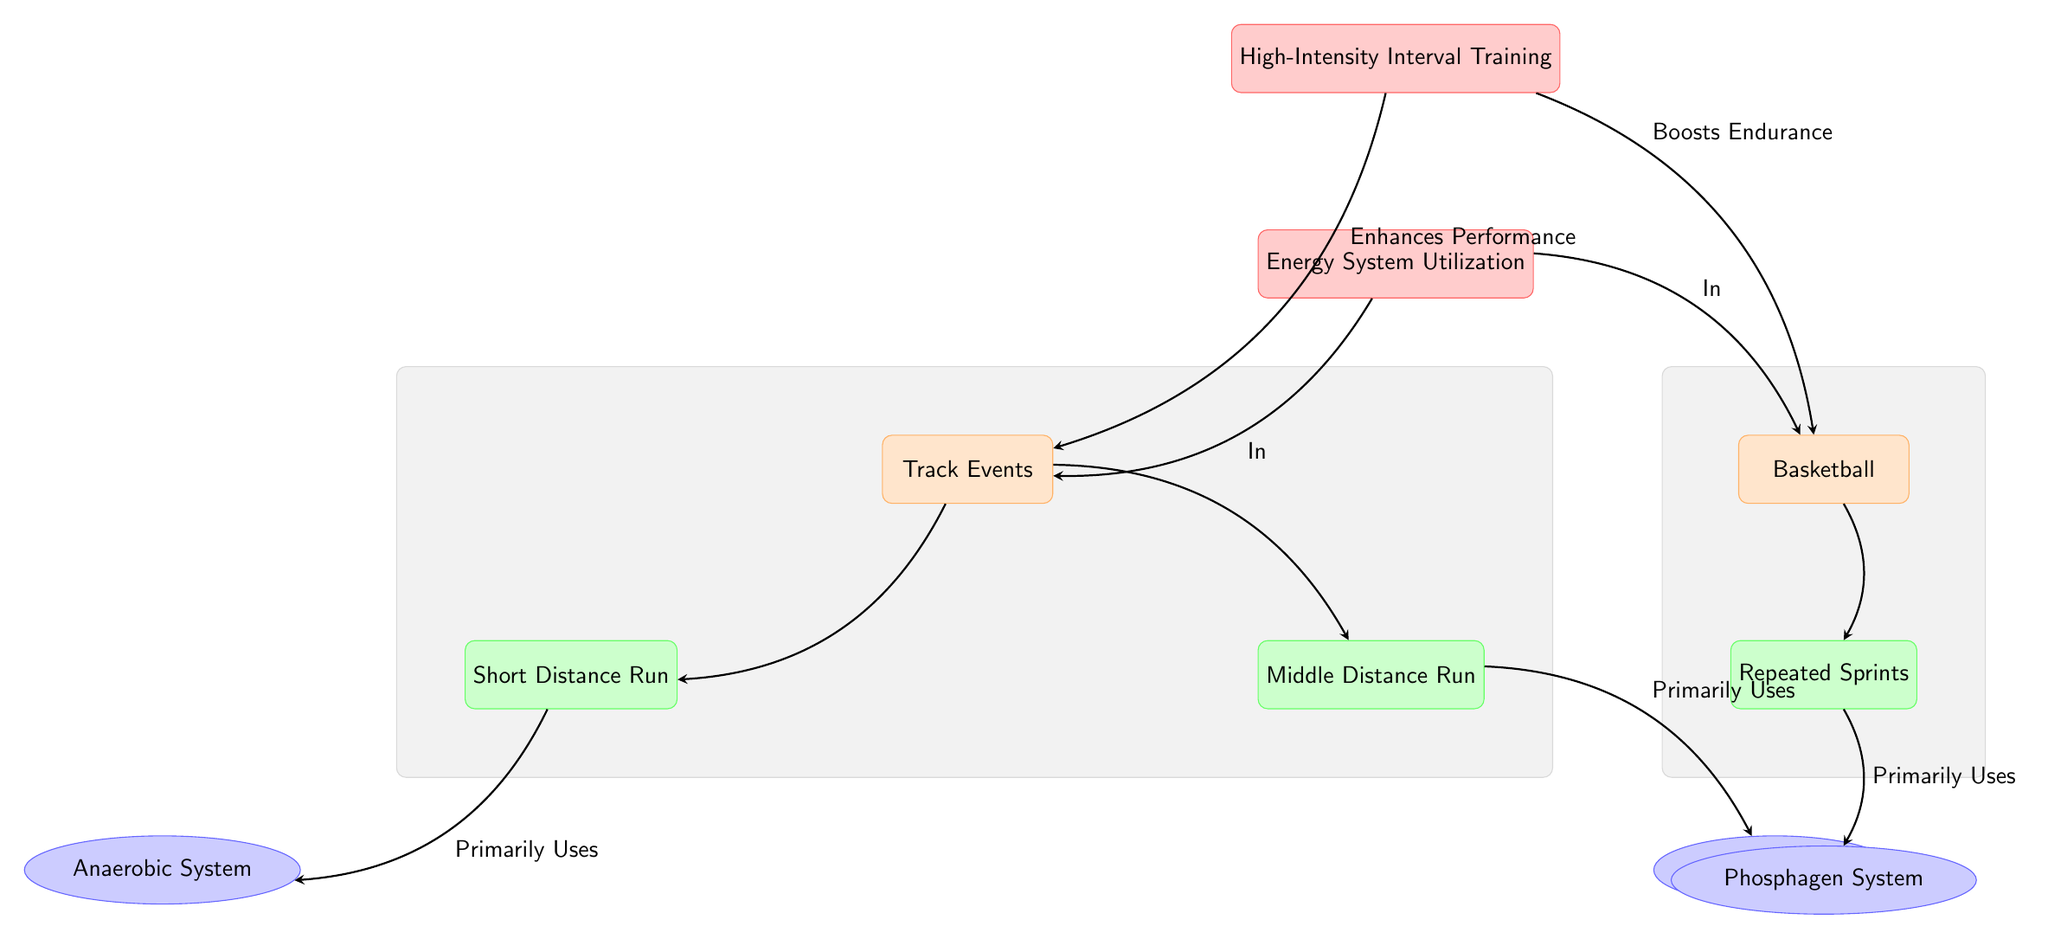What are the two primary energy systems utilized in short distance runs? The diagram indicates that the short distance runs primarily use the anaerobic system as shown by the arrow from the short distance run to the anaerobic system.
Answer: Anaerobic System What type of training enhances performance in track events? The arrow labeled "Enhances Performance" in the diagram points from "High-Intensity Interval Training" to "Track Events," indicating that HIIT is involved in enhancing performance.
Answer: High-Intensity Interval Training Which sport has a specific focus on repeated sprints? The diagram connects the basketball node to the repeated sprints node with an arrow. This establishes that repeated sprints is associated with basketball.
Answer: Basketball What is the relationship between middle distance runs and the aerobic system? The arrow connecting the middle distance runs to the aerobic system denotes that middle distance runs primarily use the aerobic system.
Answer: Primarily Uses How many distinct events are mentioned in relation to track events? The diagram lists two events: short distance run and middle distance run, creating a total of two distinct events under track events.
Answer: 2 What does high-intensity interval training do for basketball? According to the diagram, there is an arrow pointing from high-intensity interval training to basketball along with the label "Boosts Endurance," indicating its positive effect.
Answer: Boosts Endurance Which energy system is primarily utilized in repeated sprints? The diagram shows an arrow from the repeated sprints node to the phosphagen system, illustrating that repeated sprints mainly utilize this system.
Answer: Phosphagen System How are track events and basketball connected in terms of energy system utilization? The diagram shows a common concept labeled "Energy System Utilization" that both track events and basketball connect to, indicating they share a focus on energy systems.
Answer: Energy System Utilization What color represents the nodes for the sport? Referring to the diagram, all sport nodes are represented in orange, specifically a light orange with orange outline.
Answer: Orange 